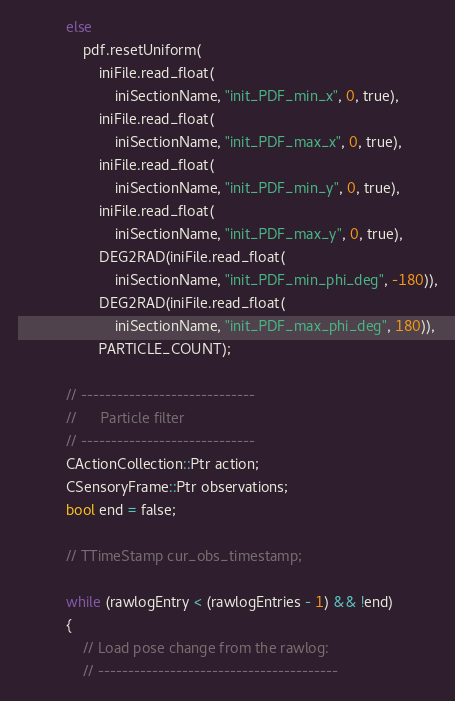<code> <loc_0><loc_0><loc_500><loc_500><_C++_>			else
				pdf.resetUniform(
					iniFile.read_float(
						iniSectionName, "init_PDF_min_x", 0, true),
					iniFile.read_float(
						iniSectionName, "init_PDF_max_x", 0, true),
					iniFile.read_float(
						iniSectionName, "init_PDF_min_y", 0, true),
					iniFile.read_float(
						iniSectionName, "init_PDF_max_y", 0, true),
					DEG2RAD(iniFile.read_float(
						iniSectionName, "init_PDF_min_phi_deg", -180)),
					DEG2RAD(iniFile.read_float(
						iniSectionName, "init_PDF_max_phi_deg", 180)),
					PARTICLE_COUNT);

			// -----------------------------
			//		Particle filter
			// -----------------------------
			CActionCollection::Ptr action;
			CSensoryFrame::Ptr observations;
			bool end = false;

			// TTimeStamp cur_obs_timestamp;

			while (rawlogEntry < (rawlogEntries - 1) && !end)
			{
				// Load pose change from the rawlog:
				// ----------------------------------------</code> 